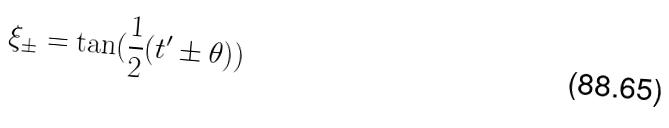<formula> <loc_0><loc_0><loc_500><loc_500>\xi _ { \pm } = \tan ( \frac { 1 } { 2 } ( t ^ { \prime } \pm \theta ) )</formula> 